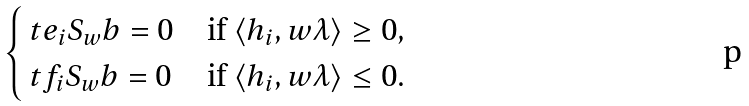Convert formula to latex. <formula><loc_0><loc_0><loc_500><loc_500>\begin{cases} \ t e _ { i } S _ { w } b = 0 & \text {if $\langle h_{i}, w\lambda\rangle \geq 0$} , \\ \ t f _ { i } S _ { w } b = 0 & \text {if $\langle h_{i}, w\lambda\rangle \leq 0$} . \end{cases}</formula> 